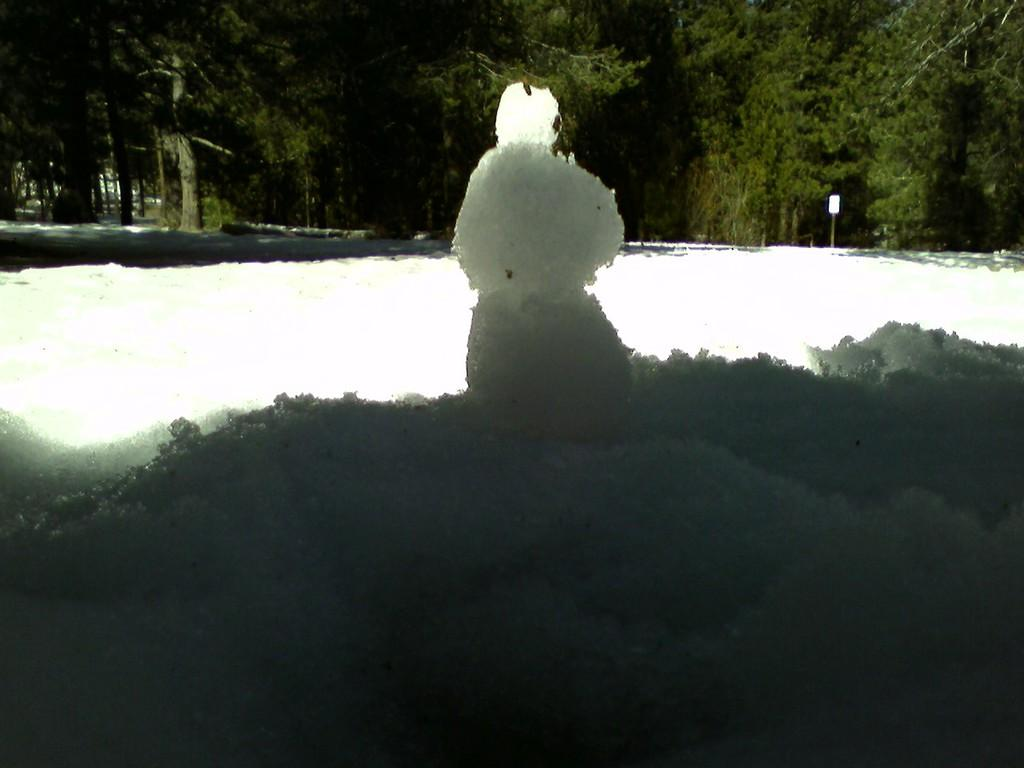What is the main subject of the picture? There is a snowman in the picture. What is the ground made of in the picture? Snow is visible at the bottom of the picture. What can be seen in the background of the picture? There are trees in the background of the picture. What is the color of the object in the picture? There is a white color board in the picture. How many eyes does the zephyr have in the picture? There is no zephyr present in the picture, and therefore no eyes can be counted. What type of book is the snowman holding in the picture? There is no book visible in the picture; the snowman is not holding any object. 